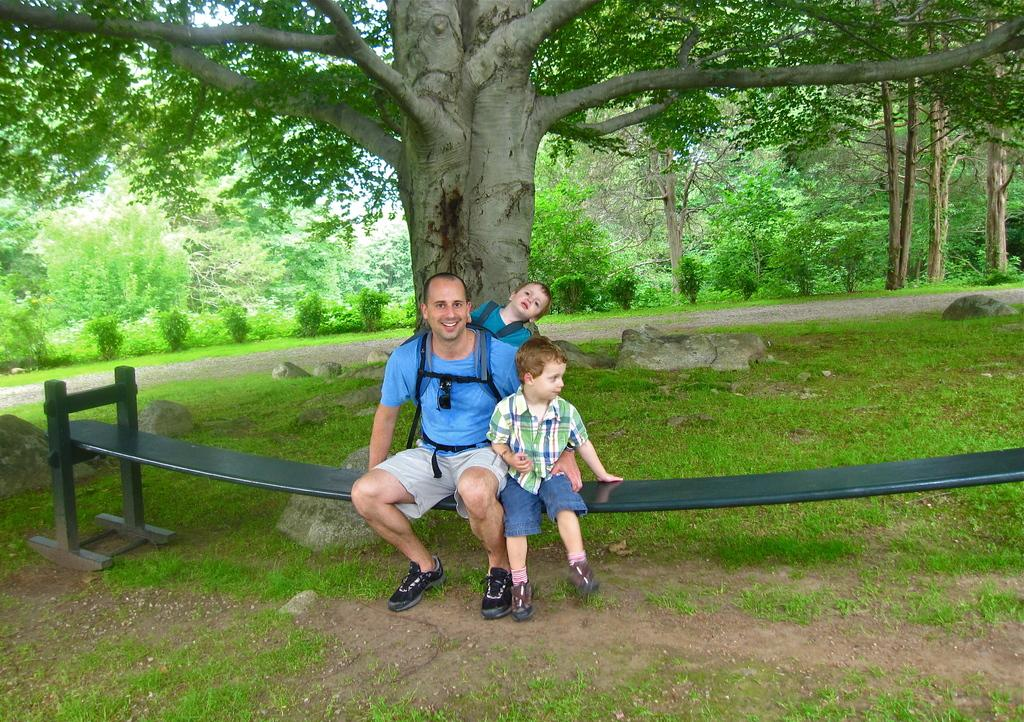What are the people in the image doing? There are persons sitting on a bench in the center of the image. What can be seen in the image besides the people on the bench? There is a tree, trees in the background, plants in the background, stones in the background, and grass on the ground in the image. What type of industry can be seen in the background of the image? There is no industry present in the image; it features a tree, trees in the background, plants in the background, stones in the background, and grass on the ground. 